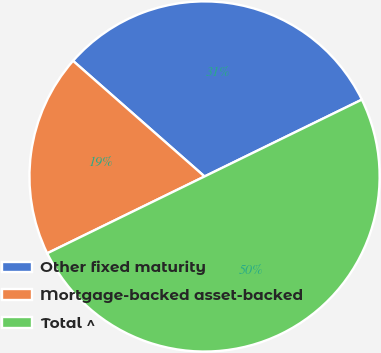<chart> <loc_0><loc_0><loc_500><loc_500><pie_chart><fcel>Other fixed maturity<fcel>Mortgage-backed asset-backed<fcel>Total ^<nl><fcel>31.29%<fcel>18.71%<fcel>50.0%<nl></chart> 